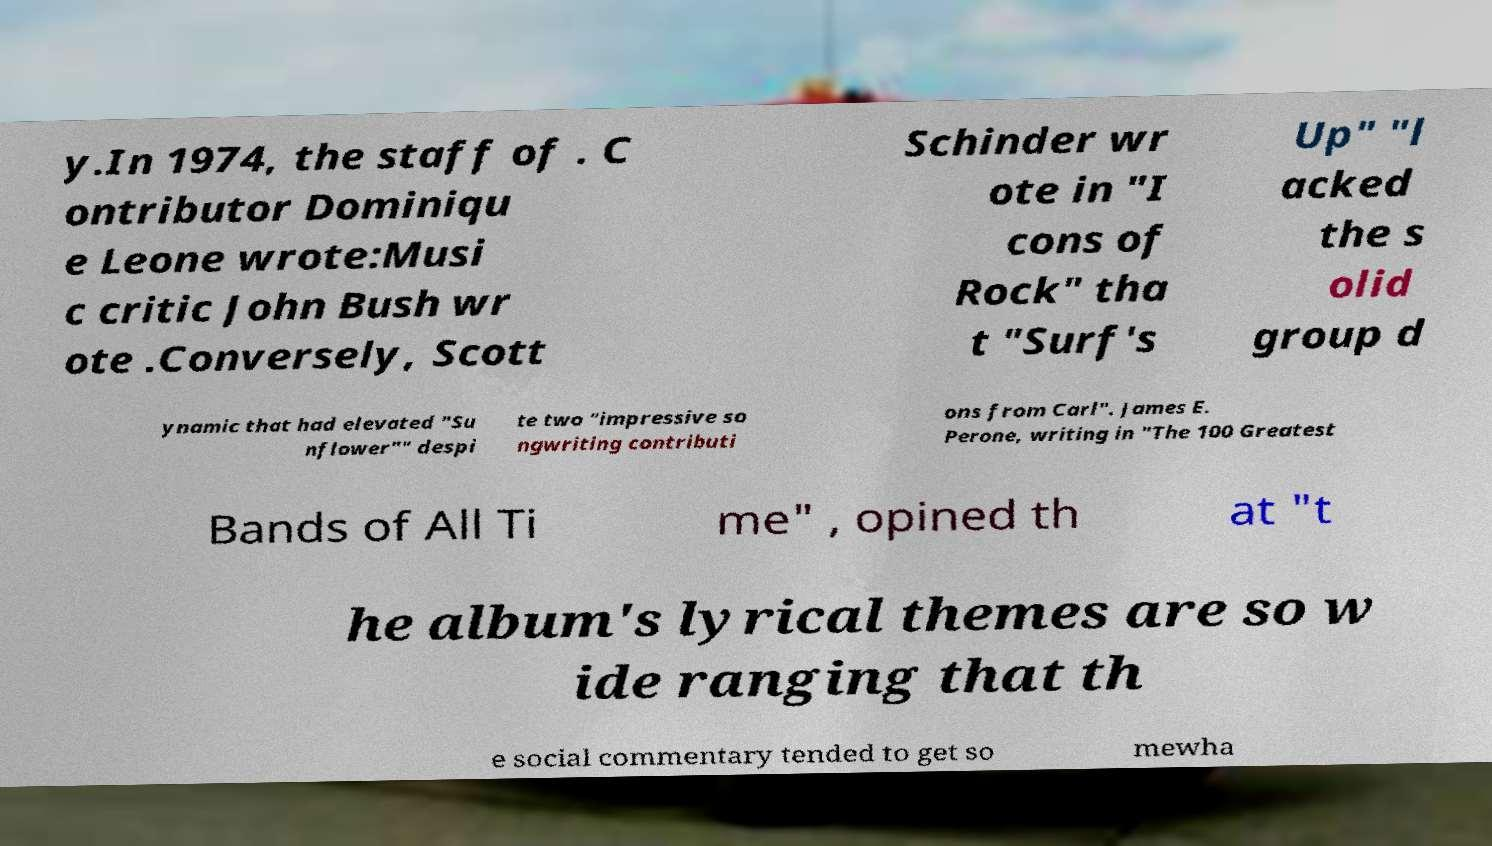Could you extract and type out the text from this image? y.In 1974, the staff of . C ontributor Dominiqu e Leone wrote:Musi c critic John Bush wr ote .Conversely, Scott Schinder wr ote in "I cons of Rock" tha t "Surf's Up" "l acked the s olid group d ynamic that had elevated "Su nflower"" despi te two "impressive so ngwriting contributi ons from Carl". James E. Perone, writing in "The 100 Greatest Bands of All Ti me" , opined th at "t he album's lyrical themes are so w ide ranging that th e social commentary tended to get so mewha 